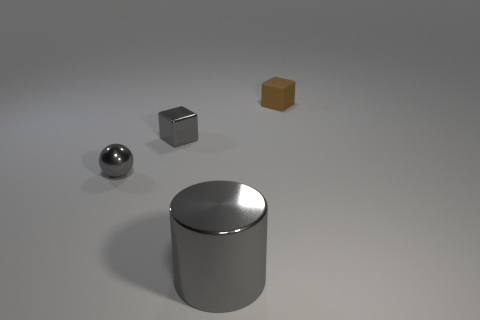The tiny metallic cube has what color?
Your answer should be very brief. Gray. What size is the gray sphere that is the same material as the gray cube?
Keep it short and to the point. Small. There is a ball that is made of the same material as the tiny gray cube; what is its color?
Your answer should be compact. Gray. Is there a matte thing that has the same size as the brown cube?
Keep it short and to the point. No. What material is the other tiny gray thing that is the same shape as the matte thing?
Offer a terse response. Metal. What shape is the rubber thing that is the same size as the gray metallic cube?
Provide a short and direct response. Cube. Are there any gray metal things that have the same shape as the small rubber object?
Give a very brief answer. Yes. There is a small object that is to the right of the gray shiny thing to the right of the gray shiny block; what shape is it?
Your answer should be compact. Cube. The big thing has what shape?
Your answer should be very brief. Cylinder. What material is the cube that is in front of the tiny cube that is right of the tiny shiny object on the right side of the ball made of?
Make the answer very short. Metal. 